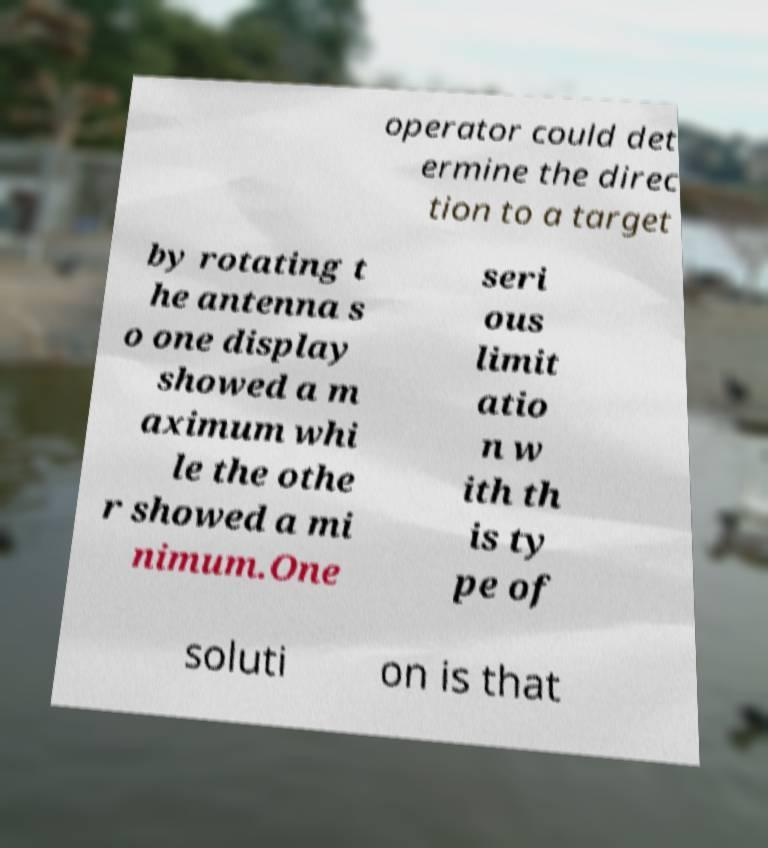Please read and relay the text visible in this image. What does it say? operator could det ermine the direc tion to a target by rotating t he antenna s o one display showed a m aximum whi le the othe r showed a mi nimum.One seri ous limit atio n w ith th is ty pe of soluti on is that 